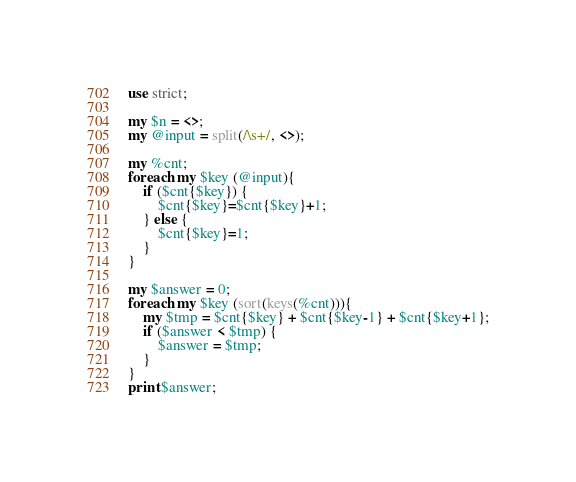Convert code to text. <code><loc_0><loc_0><loc_500><loc_500><_Perl_>use strict;

my $n = <>;
my @input = split(/\s+/, <>);

my %cnt;
foreach my $key (@input){
    if ($cnt{$key}) {
        $cnt{$key}=$cnt{$key}+1;
    } else {
        $cnt{$key}=1;
    }
}

my $answer = 0;
foreach my $key (sort(keys(%cnt))){
    my $tmp = $cnt{$key} + $cnt{$key-1} + $cnt{$key+1};
    if ($answer < $tmp) {
        $answer = $tmp;
    }
}
print $answer;</code> 